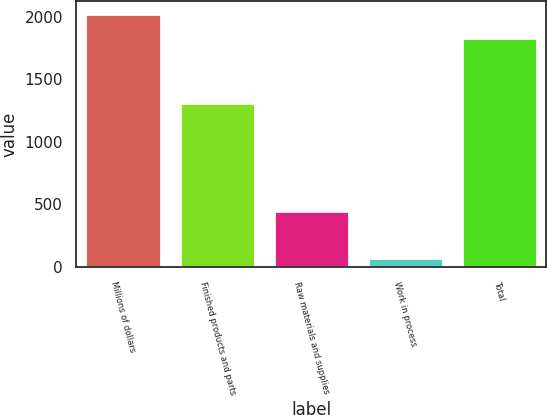Convert chart to OTSL. <chart><loc_0><loc_0><loc_500><loc_500><bar_chart><fcel>Millions of dollars<fcel>Finished products and parts<fcel>Raw materials and supplies<fcel>Work in process<fcel>Total<nl><fcel>2021.8<fcel>1312<fcel>446<fcel>70<fcel>1828<nl></chart> 